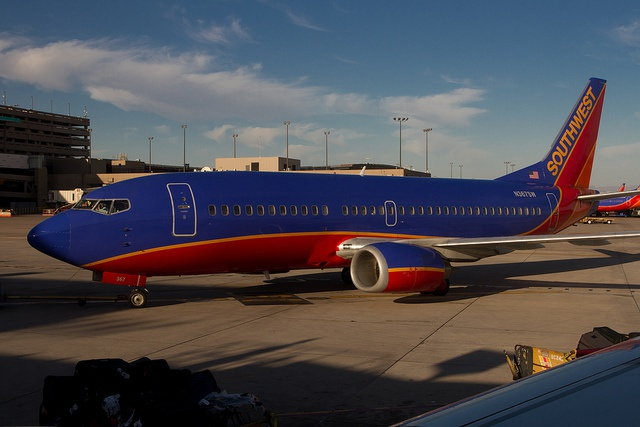Describe the objects in this image and their specific colors. I can see airplane in blue, navy, maroon, and black tones, backpack in blue, black, maroon, and gray tones, suitcase in black and blue tones, suitcase in blue, black, and gray tones, and backpack in black and blue tones in this image. 